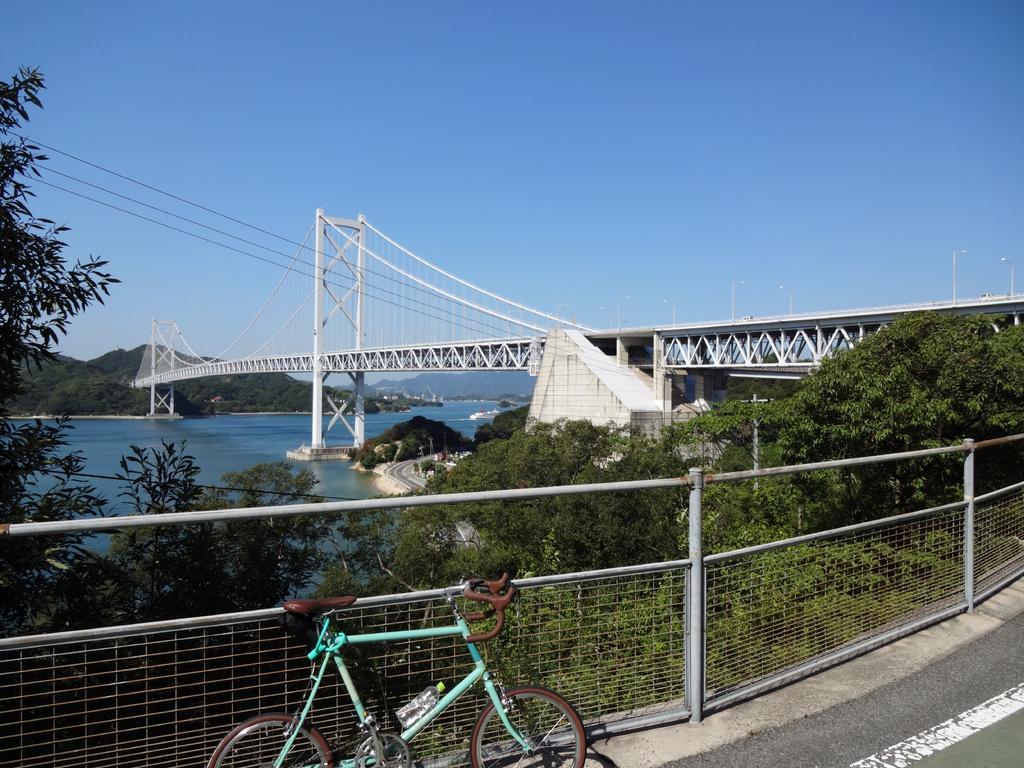In one or two sentences, can you explain what this image depicts? In this image, we can see a bicycle on the road and in the background, there are trees, a bridge and we can see a fence, hills and there is water. At the top, there is sky. 